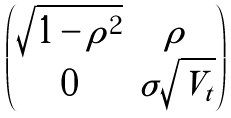<formula> <loc_0><loc_0><loc_500><loc_500>\begin{pmatrix} \sqrt { 1 - \rho ^ { 2 } } & \rho \\ 0 & \sigma \sqrt { V _ { t } } \end{pmatrix}</formula> 